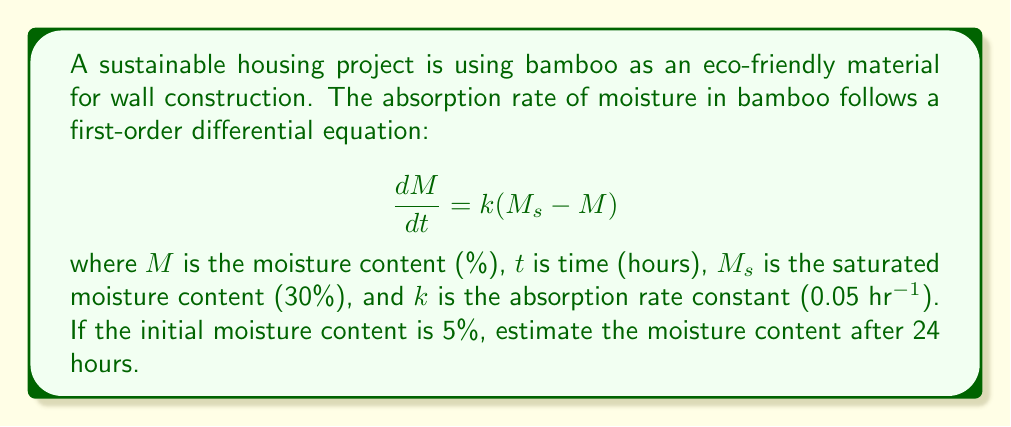Give your solution to this math problem. To solve this first-order differential equation, we follow these steps:

1) The general solution for this type of equation is:

   $$M = M_s + (M_0 - M_s)e^{-kt}$$

   where $M_0$ is the initial moisture content.

2) We are given:
   $M_s = 30\%$
   $k = 0.05$ hr$^{-1}$
   $M_0 = 5\%$
   $t = 24$ hours

3) Substituting these values into the equation:

   $$M = 30 + (5 - 30)e^{-0.05(24)}$$

4) Simplify:
   $$M = 30 - 25e^{-1.2}$$

5) Calculate $e^{-1.2}$:
   $$e^{-1.2} \approx 0.3012$$

6) Substitute this value:
   $$M = 30 - 25(0.3012)$$
   $$M = 30 - 7.53$$
   $$M = 22.47\%$$

Therefore, after 24 hours, the moisture content of the bamboo will be approximately 22.47%.
Answer: 22.47% 